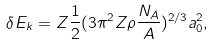Convert formula to latex. <formula><loc_0><loc_0><loc_500><loc_500>\delta E _ { k } = Z \frac { 1 } { 2 } ( 3 \pi ^ { 2 } Z \rho \frac { N _ { A } } { A } ) ^ { 2 / 3 } a _ { 0 } ^ { 2 } ,</formula> 